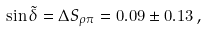Convert formula to latex. <formula><loc_0><loc_0><loc_500><loc_500>\sin \tilde { \delta } = \Delta S _ { \rho \pi } = 0 . 0 9 \pm 0 . 1 3 \, ,</formula> 